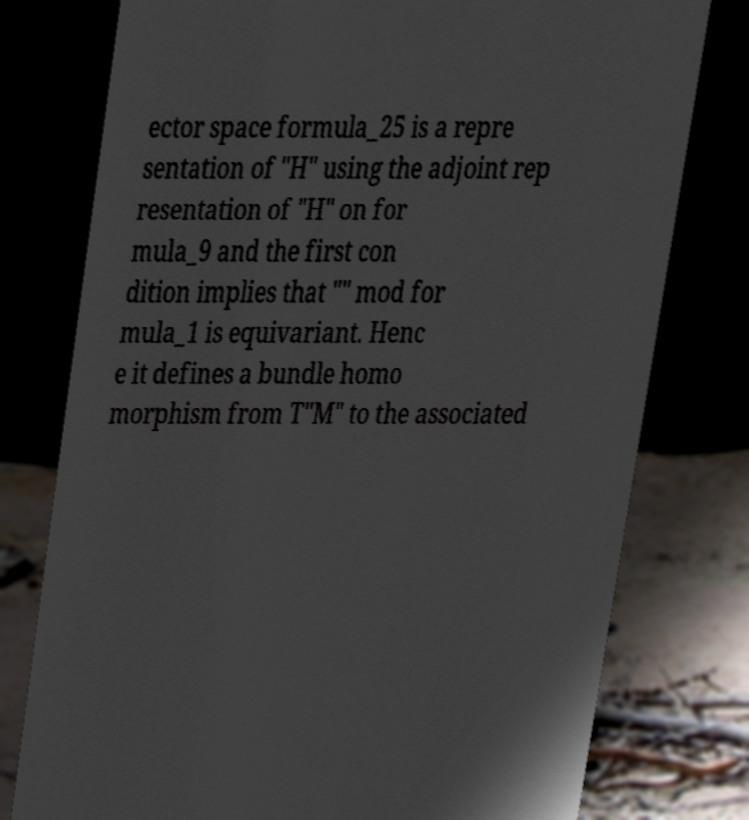What messages or text are displayed in this image? I need them in a readable, typed format. ector space formula_25 is a repre sentation of "H" using the adjoint rep resentation of "H" on for mula_9 and the first con dition implies that "" mod for mula_1 is equivariant. Henc e it defines a bundle homo morphism from T"M" to the associated 